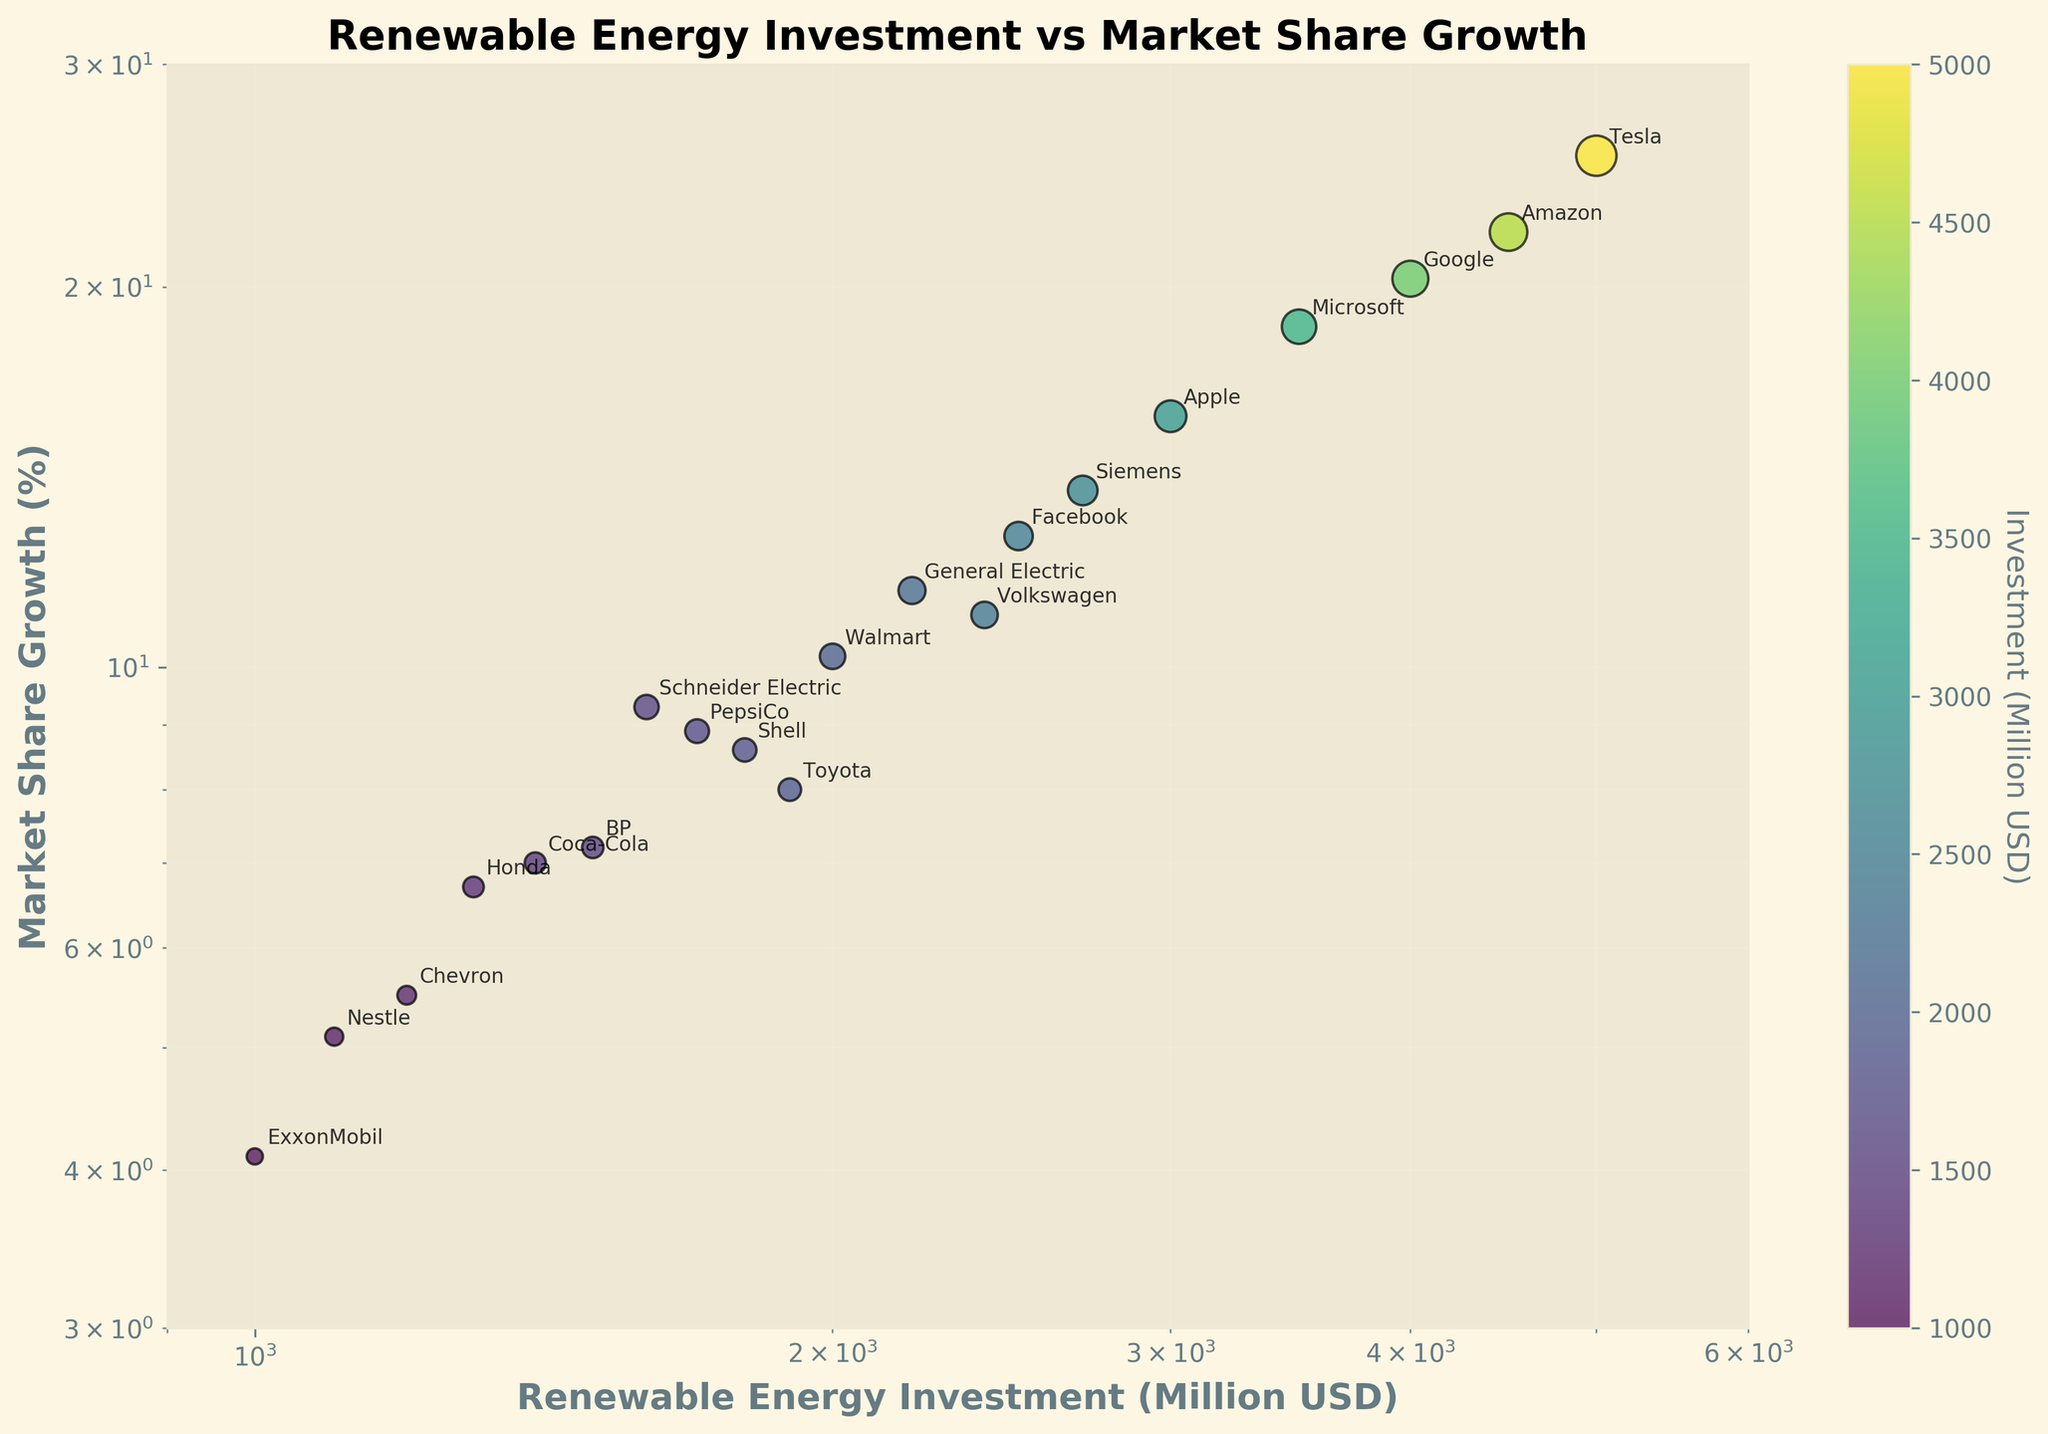What is the title of the plot? The title of the plot is displayed at the top center of the figure. It is usually written in a larger and bold font.
Answer: Renewable Energy Investment vs Market Share Growth How many companies are represented in the plot? To find the number of companies, count the number of data points (annotated labels) in the scatter plot. Each point represents a different company.
Answer: 20 Which company has the highest renewable energy investment? Identify the point with the highest value on the x-axis, as this axis represents Renewable Energy Investment. The label next to this point indicates the company with the highest investment.
Answer: Tesla Which company has the lowest market share growth? Identify the point with the lowest value on the y-axis, as this axis represents Market Share Growth. The label next to this point indicates the company with the lowest growth.
Answer: ExxonMobil Which companies have a renewable energy investment greater than 4000 million USD? Look for points where the x-axis value is greater than 4000 and note the company labels next to these points.
Answer: Tesla, Google, Amazon What is the market share growth range for companies that invested between 1000 and 2000 million USD in renewable energy? Identify the data points between 1000 and 2000 on the x-axis, and observe their corresponding y-axis values to find the growth range.
Answer: 4.1% to 11.5% Which company has a higher market share growth, Microsoft or Apple? Locate the points (labels) for Microsoft and Apple, and compare their positions along the y-axis (Market Share Growth).
Answer: Microsoft What is the average market share growth of Tesla, Google, and Amazon? Locate the y-axis values for Tesla (25.4), Google (20.3), and Amazon (22.1), sum these values and divide by 3 to find the average.
Answer: 22.6% Based on the plot, describe the relationship between renewable energy investment and market share growth. Observe the general trend of the data points in the scatter plot. As the x-axis (investment) value increases, note the changes in the y-axis (growth) value. A positive correlation suggests that higher investment is generally associated with higher market share growth.
Answer: Positive correlation (higher investment generally leads to higher growth) 